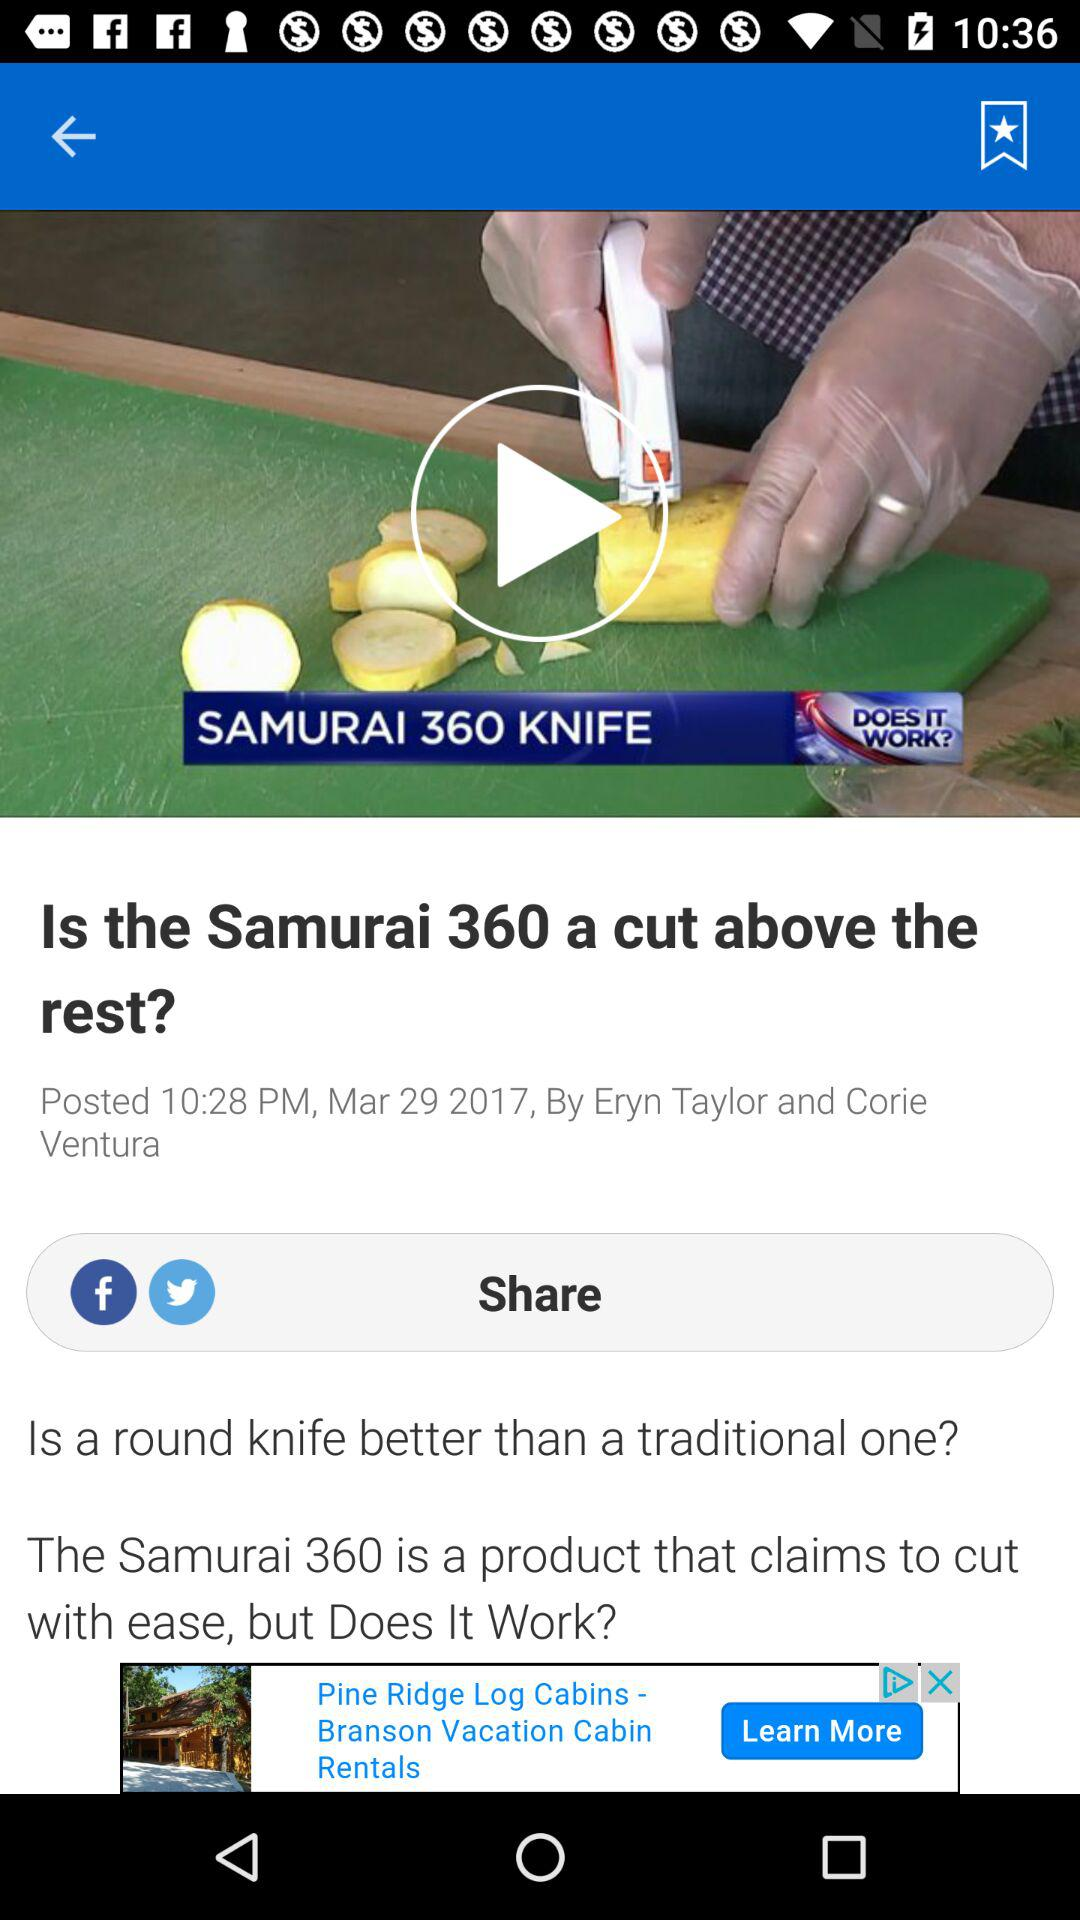On what date was the article posted? The article was posted on March 29, 2017. 